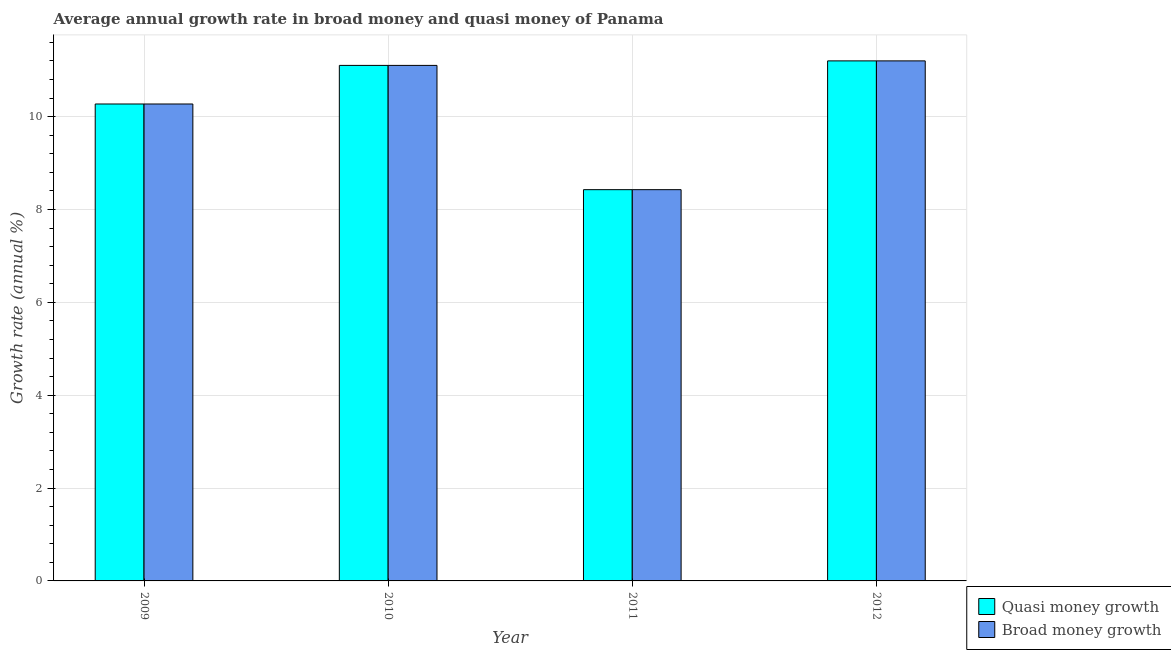How many different coloured bars are there?
Provide a short and direct response. 2. Are the number of bars per tick equal to the number of legend labels?
Keep it short and to the point. Yes. Are the number of bars on each tick of the X-axis equal?
Keep it short and to the point. Yes. How many bars are there on the 1st tick from the right?
Keep it short and to the point. 2. What is the label of the 3rd group of bars from the left?
Provide a succinct answer. 2011. What is the annual growth rate in quasi money in 2012?
Offer a terse response. 11.2. Across all years, what is the maximum annual growth rate in broad money?
Ensure brevity in your answer.  11.2. Across all years, what is the minimum annual growth rate in quasi money?
Your answer should be compact. 8.43. In which year was the annual growth rate in broad money maximum?
Make the answer very short. 2012. What is the total annual growth rate in quasi money in the graph?
Make the answer very short. 41.01. What is the difference between the annual growth rate in broad money in 2010 and that in 2011?
Offer a terse response. 2.68. What is the difference between the annual growth rate in broad money in 2012 and the annual growth rate in quasi money in 2009?
Provide a succinct answer. 0.93. What is the average annual growth rate in quasi money per year?
Your answer should be very brief. 10.25. In the year 2009, what is the difference between the annual growth rate in quasi money and annual growth rate in broad money?
Provide a succinct answer. 0. In how many years, is the annual growth rate in quasi money greater than 10.8 %?
Provide a short and direct response. 2. What is the ratio of the annual growth rate in broad money in 2009 to that in 2012?
Offer a very short reply. 0.92. What is the difference between the highest and the second highest annual growth rate in quasi money?
Make the answer very short. 0.1. What is the difference between the highest and the lowest annual growth rate in broad money?
Your answer should be compact. 2.77. Is the sum of the annual growth rate in broad money in 2009 and 2010 greater than the maximum annual growth rate in quasi money across all years?
Provide a short and direct response. Yes. What does the 1st bar from the left in 2011 represents?
Provide a succinct answer. Quasi money growth. What does the 2nd bar from the right in 2009 represents?
Your answer should be compact. Quasi money growth. What is the difference between two consecutive major ticks on the Y-axis?
Make the answer very short. 2. Are the values on the major ticks of Y-axis written in scientific E-notation?
Offer a very short reply. No. Does the graph contain any zero values?
Your response must be concise. No. How are the legend labels stacked?
Your answer should be compact. Vertical. What is the title of the graph?
Keep it short and to the point. Average annual growth rate in broad money and quasi money of Panama. What is the label or title of the X-axis?
Keep it short and to the point. Year. What is the label or title of the Y-axis?
Give a very brief answer. Growth rate (annual %). What is the Growth rate (annual %) of Quasi money growth in 2009?
Your response must be concise. 10.27. What is the Growth rate (annual %) of Broad money growth in 2009?
Provide a succinct answer. 10.27. What is the Growth rate (annual %) of Quasi money growth in 2010?
Your response must be concise. 11.1. What is the Growth rate (annual %) of Broad money growth in 2010?
Offer a terse response. 11.1. What is the Growth rate (annual %) in Quasi money growth in 2011?
Your answer should be very brief. 8.43. What is the Growth rate (annual %) in Broad money growth in 2011?
Keep it short and to the point. 8.43. What is the Growth rate (annual %) of Quasi money growth in 2012?
Provide a short and direct response. 11.2. What is the Growth rate (annual %) of Broad money growth in 2012?
Offer a terse response. 11.2. Across all years, what is the maximum Growth rate (annual %) in Quasi money growth?
Provide a short and direct response. 11.2. Across all years, what is the maximum Growth rate (annual %) of Broad money growth?
Ensure brevity in your answer.  11.2. Across all years, what is the minimum Growth rate (annual %) in Quasi money growth?
Your response must be concise. 8.43. Across all years, what is the minimum Growth rate (annual %) in Broad money growth?
Make the answer very short. 8.43. What is the total Growth rate (annual %) in Quasi money growth in the graph?
Your answer should be compact. 41.01. What is the total Growth rate (annual %) in Broad money growth in the graph?
Provide a short and direct response. 41.01. What is the difference between the Growth rate (annual %) in Quasi money growth in 2009 and that in 2010?
Offer a terse response. -0.83. What is the difference between the Growth rate (annual %) in Broad money growth in 2009 and that in 2010?
Provide a succinct answer. -0.83. What is the difference between the Growth rate (annual %) in Quasi money growth in 2009 and that in 2011?
Your answer should be compact. 1.85. What is the difference between the Growth rate (annual %) in Broad money growth in 2009 and that in 2011?
Provide a short and direct response. 1.85. What is the difference between the Growth rate (annual %) of Quasi money growth in 2009 and that in 2012?
Provide a succinct answer. -0.93. What is the difference between the Growth rate (annual %) in Broad money growth in 2009 and that in 2012?
Make the answer very short. -0.93. What is the difference between the Growth rate (annual %) of Quasi money growth in 2010 and that in 2011?
Your answer should be compact. 2.68. What is the difference between the Growth rate (annual %) of Broad money growth in 2010 and that in 2011?
Your answer should be very brief. 2.68. What is the difference between the Growth rate (annual %) of Quasi money growth in 2010 and that in 2012?
Your response must be concise. -0.1. What is the difference between the Growth rate (annual %) in Broad money growth in 2010 and that in 2012?
Your response must be concise. -0.1. What is the difference between the Growth rate (annual %) in Quasi money growth in 2011 and that in 2012?
Your response must be concise. -2.77. What is the difference between the Growth rate (annual %) of Broad money growth in 2011 and that in 2012?
Give a very brief answer. -2.77. What is the difference between the Growth rate (annual %) of Quasi money growth in 2009 and the Growth rate (annual %) of Broad money growth in 2010?
Make the answer very short. -0.83. What is the difference between the Growth rate (annual %) in Quasi money growth in 2009 and the Growth rate (annual %) in Broad money growth in 2011?
Your answer should be compact. 1.85. What is the difference between the Growth rate (annual %) of Quasi money growth in 2009 and the Growth rate (annual %) of Broad money growth in 2012?
Your answer should be very brief. -0.93. What is the difference between the Growth rate (annual %) of Quasi money growth in 2010 and the Growth rate (annual %) of Broad money growth in 2011?
Make the answer very short. 2.68. What is the difference between the Growth rate (annual %) of Quasi money growth in 2010 and the Growth rate (annual %) of Broad money growth in 2012?
Give a very brief answer. -0.1. What is the difference between the Growth rate (annual %) in Quasi money growth in 2011 and the Growth rate (annual %) in Broad money growth in 2012?
Give a very brief answer. -2.77. What is the average Growth rate (annual %) of Quasi money growth per year?
Provide a short and direct response. 10.25. What is the average Growth rate (annual %) in Broad money growth per year?
Provide a short and direct response. 10.25. In the year 2011, what is the difference between the Growth rate (annual %) in Quasi money growth and Growth rate (annual %) in Broad money growth?
Your answer should be compact. 0. What is the ratio of the Growth rate (annual %) in Quasi money growth in 2009 to that in 2010?
Offer a terse response. 0.93. What is the ratio of the Growth rate (annual %) in Broad money growth in 2009 to that in 2010?
Your answer should be very brief. 0.93. What is the ratio of the Growth rate (annual %) of Quasi money growth in 2009 to that in 2011?
Keep it short and to the point. 1.22. What is the ratio of the Growth rate (annual %) in Broad money growth in 2009 to that in 2011?
Give a very brief answer. 1.22. What is the ratio of the Growth rate (annual %) in Quasi money growth in 2009 to that in 2012?
Keep it short and to the point. 0.92. What is the ratio of the Growth rate (annual %) in Broad money growth in 2009 to that in 2012?
Keep it short and to the point. 0.92. What is the ratio of the Growth rate (annual %) in Quasi money growth in 2010 to that in 2011?
Your response must be concise. 1.32. What is the ratio of the Growth rate (annual %) of Broad money growth in 2010 to that in 2011?
Provide a succinct answer. 1.32. What is the ratio of the Growth rate (annual %) in Quasi money growth in 2011 to that in 2012?
Keep it short and to the point. 0.75. What is the ratio of the Growth rate (annual %) in Broad money growth in 2011 to that in 2012?
Offer a very short reply. 0.75. What is the difference between the highest and the second highest Growth rate (annual %) in Quasi money growth?
Provide a short and direct response. 0.1. What is the difference between the highest and the second highest Growth rate (annual %) of Broad money growth?
Your answer should be compact. 0.1. What is the difference between the highest and the lowest Growth rate (annual %) in Quasi money growth?
Offer a terse response. 2.77. What is the difference between the highest and the lowest Growth rate (annual %) in Broad money growth?
Your answer should be compact. 2.77. 